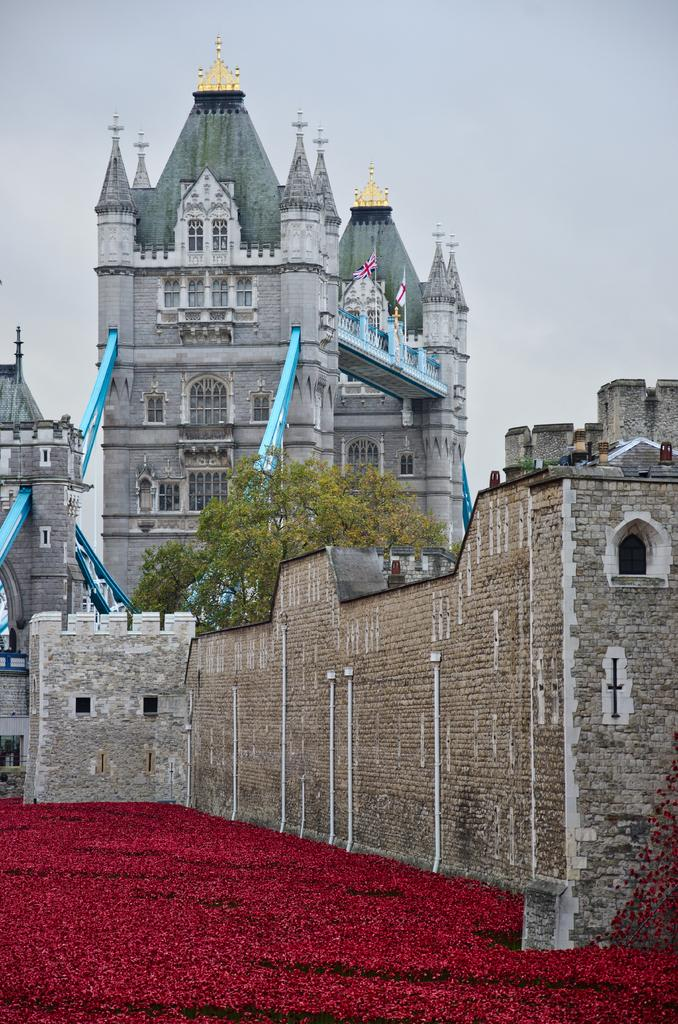What type of structures can be seen in the image? There are buildings in the image. What natural element is present in the image? There is a tree in the image. What might be decorative elements in the image? There are objects that look like flowers in the image. How would you describe the weather in the image? The sky is cloudy in the image. What architectural feature can be seen in the image? There is a wall in the image. Can you see any horses in the image? There are no horses present in the image. What type of gun is being used by the tree in the image? There is no gun present in the image, as it features buildings, a tree, flowers, a cloudy sky, and a wall. 